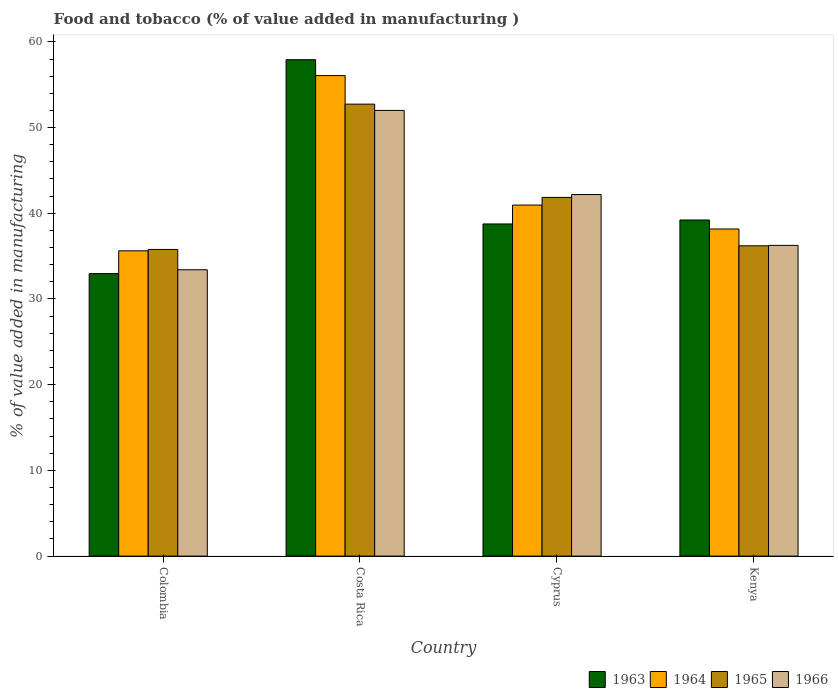Are the number of bars per tick equal to the number of legend labels?
Make the answer very short. Yes. How many bars are there on the 1st tick from the right?
Your response must be concise. 4. What is the value added in manufacturing food and tobacco in 1963 in Colombia?
Keep it short and to the point. 32.96. Across all countries, what is the maximum value added in manufacturing food and tobacco in 1964?
Your answer should be very brief. 56.07. Across all countries, what is the minimum value added in manufacturing food and tobacco in 1966?
Ensure brevity in your answer.  33.41. In which country was the value added in manufacturing food and tobacco in 1964 maximum?
Ensure brevity in your answer.  Costa Rica. What is the total value added in manufacturing food and tobacco in 1963 in the graph?
Keep it short and to the point. 168.85. What is the difference between the value added in manufacturing food and tobacco in 1965 in Colombia and that in Kenya?
Provide a succinct answer. -0.42. What is the difference between the value added in manufacturing food and tobacco in 1963 in Cyprus and the value added in manufacturing food and tobacco in 1966 in Colombia?
Your answer should be compact. 5.34. What is the average value added in manufacturing food and tobacco in 1963 per country?
Provide a short and direct response. 42.21. What is the difference between the value added in manufacturing food and tobacco of/in 1966 and value added in manufacturing food and tobacco of/in 1965 in Colombia?
Your response must be concise. -2.37. In how many countries, is the value added in manufacturing food and tobacco in 1966 greater than 32 %?
Keep it short and to the point. 4. What is the ratio of the value added in manufacturing food and tobacco in 1966 in Colombia to that in Kenya?
Provide a succinct answer. 0.92. Is the value added in manufacturing food and tobacco in 1963 in Costa Rica less than that in Kenya?
Provide a succinct answer. No. Is the difference between the value added in manufacturing food and tobacco in 1966 in Colombia and Kenya greater than the difference between the value added in manufacturing food and tobacco in 1965 in Colombia and Kenya?
Keep it short and to the point. No. What is the difference between the highest and the second highest value added in manufacturing food and tobacco in 1966?
Provide a succinct answer. -9.82. What is the difference between the highest and the lowest value added in manufacturing food and tobacco in 1964?
Your response must be concise. 20.45. In how many countries, is the value added in manufacturing food and tobacco in 1964 greater than the average value added in manufacturing food and tobacco in 1964 taken over all countries?
Offer a terse response. 1. Is it the case that in every country, the sum of the value added in manufacturing food and tobacco in 1965 and value added in manufacturing food and tobacco in 1966 is greater than the sum of value added in manufacturing food and tobacco in 1964 and value added in manufacturing food and tobacco in 1963?
Your answer should be compact. No. What does the 3rd bar from the left in Costa Rica represents?
Keep it short and to the point. 1965. What does the 4th bar from the right in Cyprus represents?
Provide a succinct answer. 1963. Are all the bars in the graph horizontal?
Offer a terse response. No. How many countries are there in the graph?
Offer a terse response. 4. Does the graph contain any zero values?
Provide a succinct answer. No. How many legend labels are there?
Offer a terse response. 4. How are the legend labels stacked?
Provide a short and direct response. Horizontal. What is the title of the graph?
Ensure brevity in your answer.  Food and tobacco (% of value added in manufacturing ). Does "2004" appear as one of the legend labels in the graph?
Provide a short and direct response. No. What is the label or title of the X-axis?
Keep it short and to the point. Country. What is the label or title of the Y-axis?
Give a very brief answer. % of value added in manufacturing. What is the % of value added in manufacturing of 1963 in Colombia?
Give a very brief answer. 32.96. What is the % of value added in manufacturing of 1964 in Colombia?
Offer a terse response. 35.62. What is the % of value added in manufacturing of 1965 in Colombia?
Offer a very short reply. 35.78. What is the % of value added in manufacturing of 1966 in Colombia?
Offer a very short reply. 33.41. What is the % of value added in manufacturing in 1963 in Costa Rica?
Your answer should be very brief. 57.92. What is the % of value added in manufacturing in 1964 in Costa Rica?
Your answer should be very brief. 56.07. What is the % of value added in manufacturing in 1965 in Costa Rica?
Keep it short and to the point. 52.73. What is the % of value added in manufacturing in 1966 in Costa Rica?
Give a very brief answer. 52. What is the % of value added in manufacturing of 1963 in Cyprus?
Make the answer very short. 38.75. What is the % of value added in manufacturing in 1964 in Cyprus?
Ensure brevity in your answer.  40.96. What is the % of value added in manufacturing of 1965 in Cyprus?
Your answer should be compact. 41.85. What is the % of value added in manufacturing in 1966 in Cyprus?
Your answer should be very brief. 42.19. What is the % of value added in manufacturing in 1963 in Kenya?
Offer a very short reply. 39.22. What is the % of value added in manufacturing of 1964 in Kenya?
Your response must be concise. 38.17. What is the % of value added in manufacturing of 1965 in Kenya?
Offer a very short reply. 36.2. What is the % of value added in manufacturing in 1966 in Kenya?
Offer a terse response. 36.25. Across all countries, what is the maximum % of value added in manufacturing of 1963?
Keep it short and to the point. 57.92. Across all countries, what is the maximum % of value added in manufacturing in 1964?
Give a very brief answer. 56.07. Across all countries, what is the maximum % of value added in manufacturing in 1965?
Your answer should be very brief. 52.73. Across all countries, what is the maximum % of value added in manufacturing in 1966?
Offer a very short reply. 52. Across all countries, what is the minimum % of value added in manufacturing in 1963?
Ensure brevity in your answer.  32.96. Across all countries, what is the minimum % of value added in manufacturing in 1964?
Ensure brevity in your answer.  35.62. Across all countries, what is the minimum % of value added in manufacturing in 1965?
Give a very brief answer. 35.78. Across all countries, what is the minimum % of value added in manufacturing of 1966?
Keep it short and to the point. 33.41. What is the total % of value added in manufacturing in 1963 in the graph?
Your response must be concise. 168.85. What is the total % of value added in manufacturing of 1964 in the graph?
Your response must be concise. 170.81. What is the total % of value added in manufacturing in 1965 in the graph?
Offer a very short reply. 166.57. What is the total % of value added in manufacturing of 1966 in the graph?
Keep it short and to the point. 163.86. What is the difference between the % of value added in manufacturing of 1963 in Colombia and that in Costa Rica?
Provide a short and direct response. -24.96. What is the difference between the % of value added in manufacturing of 1964 in Colombia and that in Costa Rica?
Give a very brief answer. -20.45. What is the difference between the % of value added in manufacturing of 1965 in Colombia and that in Costa Rica?
Give a very brief answer. -16.95. What is the difference between the % of value added in manufacturing of 1966 in Colombia and that in Costa Rica?
Give a very brief answer. -18.59. What is the difference between the % of value added in manufacturing in 1963 in Colombia and that in Cyprus?
Make the answer very short. -5.79. What is the difference between the % of value added in manufacturing of 1964 in Colombia and that in Cyprus?
Offer a terse response. -5.34. What is the difference between the % of value added in manufacturing in 1965 in Colombia and that in Cyprus?
Your answer should be very brief. -6.07. What is the difference between the % of value added in manufacturing of 1966 in Colombia and that in Cyprus?
Your answer should be very brief. -8.78. What is the difference between the % of value added in manufacturing of 1963 in Colombia and that in Kenya?
Your answer should be very brief. -6.26. What is the difference between the % of value added in manufacturing in 1964 in Colombia and that in Kenya?
Offer a terse response. -2.55. What is the difference between the % of value added in manufacturing in 1965 in Colombia and that in Kenya?
Keep it short and to the point. -0.42. What is the difference between the % of value added in manufacturing in 1966 in Colombia and that in Kenya?
Provide a succinct answer. -2.84. What is the difference between the % of value added in manufacturing in 1963 in Costa Rica and that in Cyprus?
Offer a terse response. 19.17. What is the difference between the % of value added in manufacturing in 1964 in Costa Rica and that in Cyprus?
Offer a terse response. 15.11. What is the difference between the % of value added in manufacturing in 1965 in Costa Rica and that in Cyprus?
Your answer should be very brief. 10.88. What is the difference between the % of value added in manufacturing of 1966 in Costa Rica and that in Cyprus?
Give a very brief answer. 9.82. What is the difference between the % of value added in manufacturing of 1963 in Costa Rica and that in Kenya?
Provide a short and direct response. 18.7. What is the difference between the % of value added in manufacturing of 1964 in Costa Rica and that in Kenya?
Your answer should be compact. 17.9. What is the difference between the % of value added in manufacturing in 1965 in Costa Rica and that in Kenya?
Your answer should be compact. 16.53. What is the difference between the % of value added in manufacturing in 1966 in Costa Rica and that in Kenya?
Provide a succinct answer. 15.75. What is the difference between the % of value added in manufacturing in 1963 in Cyprus and that in Kenya?
Your answer should be very brief. -0.46. What is the difference between the % of value added in manufacturing in 1964 in Cyprus and that in Kenya?
Make the answer very short. 2.79. What is the difference between the % of value added in manufacturing of 1965 in Cyprus and that in Kenya?
Offer a terse response. 5.65. What is the difference between the % of value added in manufacturing of 1966 in Cyprus and that in Kenya?
Ensure brevity in your answer.  5.93. What is the difference between the % of value added in manufacturing of 1963 in Colombia and the % of value added in manufacturing of 1964 in Costa Rica?
Your answer should be very brief. -23.11. What is the difference between the % of value added in manufacturing of 1963 in Colombia and the % of value added in manufacturing of 1965 in Costa Rica?
Offer a terse response. -19.77. What is the difference between the % of value added in manufacturing of 1963 in Colombia and the % of value added in manufacturing of 1966 in Costa Rica?
Ensure brevity in your answer.  -19.04. What is the difference between the % of value added in manufacturing in 1964 in Colombia and the % of value added in manufacturing in 1965 in Costa Rica?
Provide a short and direct response. -17.11. What is the difference between the % of value added in manufacturing of 1964 in Colombia and the % of value added in manufacturing of 1966 in Costa Rica?
Your answer should be compact. -16.38. What is the difference between the % of value added in manufacturing in 1965 in Colombia and the % of value added in manufacturing in 1966 in Costa Rica?
Offer a very short reply. -16.22. What is the difference between the % of value added in manufacturing of 1963 in Colombia and the % of value added in manufacturing of 1964 in Cyprus?
Provide a succinct answer. -8. What is the difference between the % of value added in manufacturing of 1963 in Colombia and the % of value added in manufacturing of 1965 in Cyprus?
Offer a terse response. -8.89. What is the difference between the % of value added in manufacturing of 1963 in Colombia and the % of value added in manufacturing of 1966 in Cyprus?
Provide a succinct answer. -9.23. What is the difference between the % of value added in manufacturing in 1964 in Colombia and the % of value added in manufacturing in 1965 in Cyprus?
Your answer should be very brief. -6.23. What is the difference between the % of value added in manufacturing of 1964 in Colombia and the % of value added in manufacturing of 1966 in Cyprus?
Offer a very short reply. -6.57. What is the difference between the % of value added in manufacturing of 1965 in Colombia and the % of value added in manufacturing of 1966 in Cyprus?
Keep it short and to the point. -6.41. What is the difference between the % of value added in manufacturing of 1963 in Colombia and the % of value added in manufacturing of 1964 in Kenya?
Your answer should be compact. -5.21. What is the difference between the % of value added in manufacturing in 1963 in Colombia and the % of value added in manufacturing in 1965 in Kenya?
Offer a terse response. -3.24. What is the difference between the % of value added in manufacturing in 1963 in Colombia and the % of value added in manufacturing in 1966 in Kenya?
Make the answer very short. -3.29. What is the difference between the % of value added in manufacturing of 1964 in Colombia and the % of value added in manufacturing of 1965 in Kenya?
Offer a terse response. -0.58. What is the difference between the % of value added in manufacturing of 1964 in Colombia and the % of value added in manufacturing of 1966 in Kenya?
Make the answer very short. -0.63. What is the difference between the % of value added in manufacturing of 1965 in Colombia and the % of value added in manufacturing of 1966 in Kenya?
Make the answer very short. -0.47. What is the difference between the % of value added in manufacturing in 1963 in Costa Rica and the % of value added in manufacturing in 1964 in Cyprus?
Offer a very short reply. 16.96. What is the difference between the % of value added in manufacturing of 1963 in Costa Rica and the % of value added in manufacturing of 1965 in Cyprus?
Provide a short and direct response. 16.07. What is the difference between the % of value added in manufacturing of 1963 in Costa Rica and the % of value added in manufacturing of 1966 in Cyprus?
Provide a short and direct response. 15.73. What is the difference between the % of value added in manufacturing of 1964 in Costa Rica and the % of value added in manufacturing of 1965 in Cyprus?
Provide a short and direct response. 14.21. What is the difference between the % of value added in manufacturing of 1964 in Costa Rica and the % of value added in manufacturing of 1966 in Cyprus?
Your response must be concise. 13.88. What is the difference between the % of value added in manufacturing of 1965 in Costa Rica and the % of value added in manufacturing of 1966 in Cyprus?
Make the answer very short. 10.55. What is the difference between the % of value added in manufacturing in 1963 in Costa Rica and the % of value added in manufacturing in 1964 in Kenya?
Offer a very short reply. 19.75. What is the difference between the % of value added in manufacturing in 1963 in Costa Rica and the % of value added in manufacturing in 1965 in Kenya?
Offer a terse response. 21.72. What is the difference between the % of value added in manufacturing in 1963 in Costa Rica and the % of value added in manufacturing in 1966 in Kenya?
Your response must be concise. 21.67. What is the difference between the % of value added in manufacturing of 1964 in Costa Rica and the % of value added in manufacturing of 1965 in Kenya?
Your answer should be compact. 19.86. What is the difference between the % of value added in manufacturing of 1964 in Costa Rica and the % of value added in manufacturing of 1966 in Kenya?
Your answer should be very brief. 19.81. What is the difference between the % of value added in manufacturing of 1965 in Costa Rica and the % of value added in manufacturing of 1966 in Kenya?
Offer a very short reply. 16.48. What is the difference between the % of value added in manufacturing of 1963 in Cyprus and the % of value added in manufacturing of 1964 in Kenya?
Your response must be concise. 0.59. What is the difference between the % of value added in manufacturing of 1963 in Cyprus and the % of value added in manufacturing of 1965 in Kenya?
Your answer should be compact. 2.55. What is the difference between the % of value added in manufacturing of 1963 in Cyprus and the % of value added in manufacturing of 1966 in Kenya?
Provide a short and direct response. 2.5. What is the difference between the % of value added in manufacturing of 1964 in Cyprus and the % of value added in manufacturing of 1965 in Kenya?
Offer a very short reply. 4.75. What is the difference between the % of value added in manufacturing in 1964 in Cyprus and the % of value added in manufacturing in 1966 in Kenya?
Offer a terse response. 4.7. What is the difference between the % of value added in manufacturing in 1965 in Cyprus and the % of value added in manufacturing in 1966 in Kenya?
Offer a very short reply. 5.6. What is the average % of value added in manufacturing in 1963 per country?
Your answer should be very brief. 42.21. What is the average % of value added in manufacturing in 1964 per country?
Offer a very short reply. 42.7. What is the average % of value added in manufacturing of 1965 per country?
Offer a very short reply. 41.64. What is the average % of value added in manufacturing of 1966 per country?
Offer a very short reply. 40.96. What is the difference between the % of value added in manufacturing in 1963 and % of value added in manufacturing in 1964 in Colombia?
Your response must be concise. -2.66. What is the difference between the % of value added in manufacturing in 1963 and % of value added in manufacturing in 1965 in Colombia?
Ensure brevity in your answer.  -2.82. What is the difference between the % of value added in manufacturing in 1963 and % of value added in manufacturing in 1966 in Colombia?
Give a very brief answer. -0.45. What is the difference between the % of value added in manufacturing in 1964 and % of value added in manufacturing in 1965 in Colombia?
Give a very brief answer. -0.16. What is the difference between the % of value added in manufacturing of 1964 and % of value added in manufacturing of 1966 in Colombia?
Offer a terse response. 2.21. What is the difference between the % of value added in manufacturing in 1965 and % of value added in manufacturing in 1966 in Colombia?
Keep it short and to the point. 2.37. What is the difference between the % of value added in manufacturing in 1963 and % of value added in manufacturing in 1964 in Costa Rica?
Ensure brevity in your answer.  1.85. What is the difference between the % of value added in manufacturing in 1963 and % of value added in manufacturing in 1965 in Costa Rica?
Offer a terse response. 5.19. What is the difference between the % of value added in manufacturing in 1963 and % of value added in manufacturing in 1966 in Costa Rica?
Provide a succinct answer. 5.92. What is the difference between the % of value added in manufacturing of 1964 and % of value added in manufacturing of 1965 in Costa Rica?
Make the answer very short. 3.33. What is the difference between the % of value added in manufacturing of 1964 and % of value added in manufacturing of 1966 in Costa Rica?
Offer a terse response. 4.06. What is the difference between the % of value added in manufacturing of 1965 and % of value added in manufacturing of 1966 in Costa Rica?
Provide a short and direct response. 0.73. What is the difference between the % of value added in manufacturing of 1963 and % of value added in manufacturing of 1964 in Cyprus?
Your answer should be very brief. -2.2. What is the difference between the % of value added in manufacturing of 1963 and % of value added in manufacturing of 1965 in Cyprus?
Provide a short and direct response. -3.1. What is the difference between the % of value added in manufacturing of 1963 and % of value added in manufacturing of 1966 in Cyprus?
Ensure brevity in your answer.  -3.43. What is the difference between the % of value added in manufacturing of 1964 and % of value added in manufacturing of 1965 in Cyprus?
Your answer should be compact. -0.9. What is the difference between the % of value added in manufacturing of 1964 and % of value added in manufacturing of 1966 in Cyprus?
Ensure brevity in your answer.  -1.23. What is the difference between the % of value added in manufacturing in 1965 and % of value added in manufacturing in 1966 in Cyprus?
Make the answer very short. -0.33. What is the difference between the % of value added in manufacturing in 1963 and % of value added in manufacturing in 1964 in Kenya?
Ensure brevity in your answer.  1.05. What is the difference between the % of value added in manufacturing of 1963 and % of value added in manufacturing of 1965 in Kenya?
Provide a succinct answer. 3.01. What is the difference between the % of value added in manufacturing of 1963 and % of value added in manufacturing of 1966 in Kenya?
Your answer should be very brief. 2.96. What is the difference between the % of value added in manufacturing of 1964 and % of value added in manufacturing of 1965 in Kenya?
Offer a very short reply. 1.96. What is the difference between the % of value added in manufacturing in 1964 and % of value added in manufacturing in 1966 in Kenya?
Offer a terse response. 1.91. What is the difference between the % of value added in manufacturing of 1965 and % of value added in manufacturing of 1966 in Kenya?
Offer a very short reply. -0.05. What is the ratio of the % of value added in manufacturing in 1963 in Colombia to that in Costa Rica?
Ensure brevity in your answer.  0.57. What is the ratio of the % of value added in manufacturing in 1964 in Colombia to that in Costa Rica?
Your answer should be very brief. 0.64. What is the ratio of the % of value added in manufacturing in 1965 in Colombia to that in Costa Rica?
Your answer should be very brief. 0.68. What is the ratio of the % of value added in manufacturing of 1966 in Colombia to that in Costa Rica?
Provide a short and direct response. 0.64. What is the ratio of the % of value added in manufacturing in 1963 in Colombia to that in Cyprus?
Your response must be concise. 0.85. What is the ratio of the % of value added in manufacturing in 1964 in Colombia to that in Cyprus?
Give a very brief answer. 0.87. What is the ratio of the % of value added in manufacturing of 1965 in Colombia to that in Cyprus?
Your response must be concise. 0.85. What is the ratio of the % of value added in manufacturing of 1966 in Colombia to that in Cyprus?
Give a very brief answer. 0.79. What is the ratio of the % of value added in manufacturing of 1963 in Colombia to that in Kenya?
Provide a short and direct response. 0.84. What is the ratio of the % of value added in manufacturing in 1964 in Colombia to that in Kenya?
Ensure brevity in your answer.  0.93. What is the ratio of the % of value added in manufacturing in 1965 in Colombia to that in Kenya?
Your response must be concise. 0.99. What is the ratio of the % of value added in manufacturing in 1966 in Colombia to that in Kenya?
Your answer should be very brief. 0.92. What is the ratio of the % of value added in manufacturing in 1963 in Costa Rica to that in Cyprus?
Keep it short and to the point. 1.49. What is the ratio of the % of value added in manufacturing of 1964 in Costa Rica to that in Cyprus?
Offer a terse response. 1.37. What is the ratio of the % of value added in manufacturing of 1965 in Costa Rica to that in Cyprus?
Provide a succinct answer. 1.26. What is the ratio of the % of value added in manufacturing of 1966 in Costa Rica to that in Cyprus?
Keep it short and to the point. 1.23. What is the ratio of the % of value added in manufacturing of 1963 in Costa Rica to that in Kenya?
Your answer should be compact. 1.48. What is the ratio of the % of value added in manufacturing of 1964 in Costa Rica to that in Kenya?
Offer a terse response. 1.47. What is the ratio of the % of value added in manufacturing of 1965 in Costa Rica to that in Kenya?
Offer a terse response. 1.46. What is the ratio of the % of value added in manufacturing of 1966 in Costa Rica to that in Kenya?
Provide a succinct answer. 1.43. What is the ratio of the % of value added in manufacturing in 1963 in Cyprus to that in Kenya?
Ensure brevity in your answer.  0.99. What is the ratio of the % of value added in manufacturing in 1964 in Cyprus to that in Kenya?
Offer a terse response. 1.07. What is the ratio of the % of value added in manufacturing of 1965 in Cyprus to that in Kenya?
Offer a very short reply. 1.16. What is the ratio of the % of value added in manufacturing of 1966 in Cyprus to that in Kenya?
Keep it short and to the point. 1.16. What is the difference between the highest and the second highest % of value added in manufacturing in 1963?
Provide a short and direct response. 18.7. What is the difference between the highest and the second highest % of value added in manufacturing of 1964?
Ensure brevity in your answer.  15.11. What is the difference between the highest and the second highest % of value added in manufacturing of 1965?
Provide a short and direct response. 10.88. What is the difference between the highest and the second highest % of value added in manufacturing of 1966?
Your answer should be very brief. 9.82. What is the difference between the highest and the lowest % of value added in manufacturing of 1963?
Your answer should be very brief. 24.96. What is the difference between the highest and the lowest % of value added in manufacturing in 1964?
Your answer should be very brief. 20.45. What is the difference between the highest and the lowest % of value added in manufacturing of 1965?
Provide a succinct answer. 16.95. What is the difference between the highest and the lowest % of value added in manufacturing in 1966?
Ensure brevity in your answer.  18.59. 